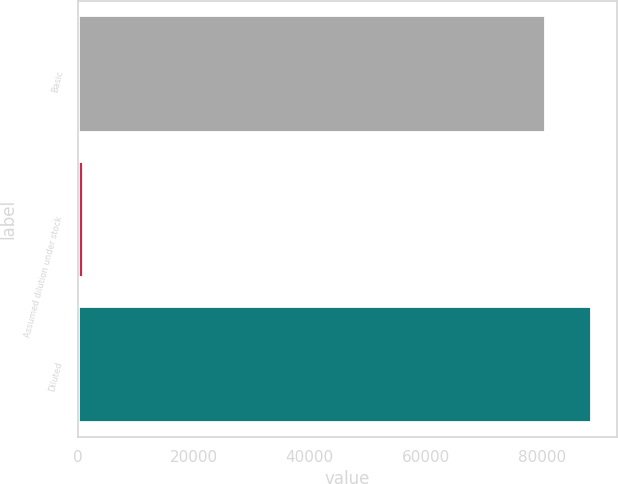Convert chart to OTSL. <chart><loc_0><loc_0><loc_500><loc_500><bar_chart><fcel>Basic<fcel>Assumed dilution under stock<fcel>Diluted<nl><fcel>80456<fcel>1011<fcel>88501.6<nl></chart> 